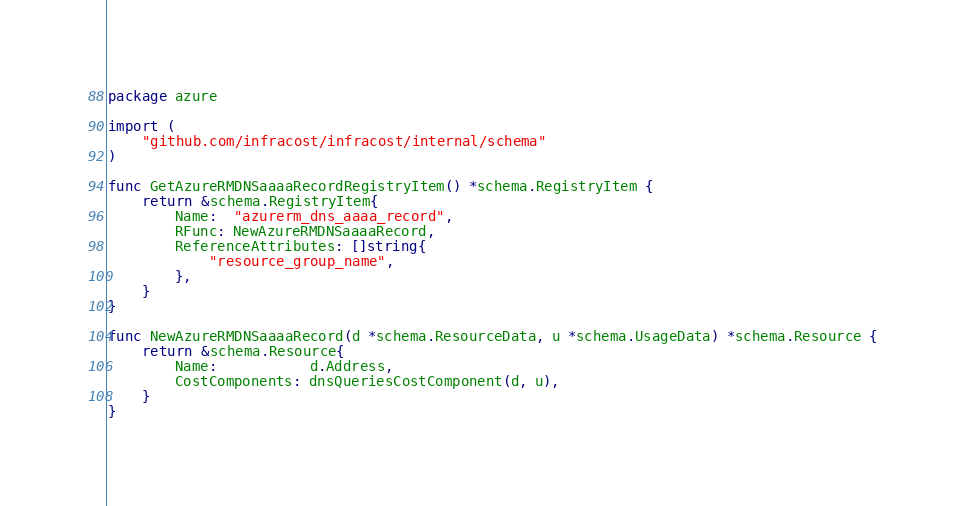Convert code to text. <code><loc_0><loc_0><loc_500><loc_500><_Go_>package azure

import (
	"github.com/infracost/infracost/internal/schema"
)

func GetAzureRMDNSaaaaRecordRegistryItem() *schema.RegistryItem {
	return &schema.RegistryItem{
		Name:  "azurerm_dns_aaaa_record",
		RFunc: NewAzureRMDNSaaaaRecord,
		ReferenceAttributes: []string{
			"resource_group_name",
		},
	}
}

func NewAzureRMDNSaaaaRecord(d *schema.ResourceData, u *schema.UsageData) *schema.Resource {
	return &schema.Resource{
		Name:           d.Address,
		CostComponents: dnsQueriesCostComponent(d, u),
	}
}
</code> 